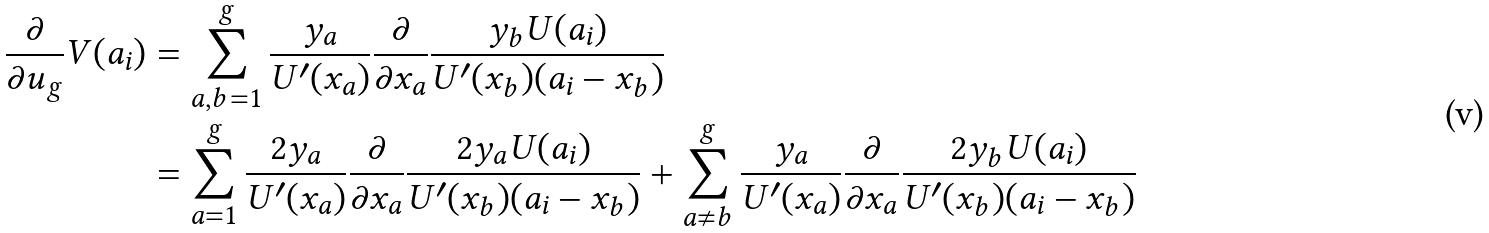Convert formula to latex. <formula><loc_0><loc_0><loc_500><loc_500>\frac { \partial } { \partial u _ { g } } V ( a _ { i } ) & = \sum _ { a , b = 1 } ^ { g } \frac { y _ { a } } { U ^ { \prime } ( x _ { a } ) } \frac { \partial } { \partial x _ { a } } \frac { y _ { b } U ( a _ { i } ) } { U ^ { \prime } ( x _ { b } ) ( a _ { i } - x _ { b } ) } \\ & = \sum _ { a = 1 } ^ { g } \frac { 2 y _ { a } } { U ^ { \prime } ( x _ { a } ) } \frac { \partial } { \partial x _ { a } } \frac { 2 y _ { a } U ( a _ { i } ) } { U ^ { \prime } ( x _ { b } ) ( a _ { i } - x _ { b } ) } + \sum _ { a \neq b } ^ { g } \frac { y _ { a } } { U ^ { \prime } ( x _ { a } ) } \frac { \partial } { \partial x _ { a } } \frac { 2 y _ { b } U ( a _ { i } ) } { U ^ { \prime } ( x _ { b } ) ( a _ { i } - x _ { b } ) } \\</formula> 